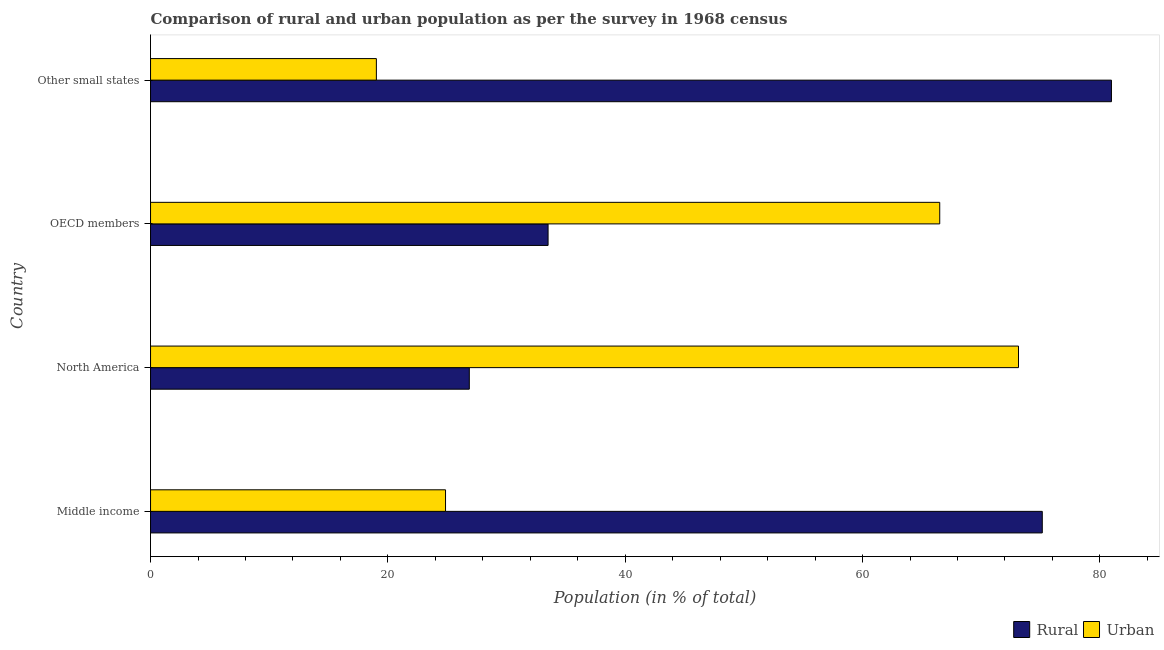How many different coloured bars are there?
Your response must be concise. 2. How many groups of bars are there?
Ensure brevity in your answer.  4. Are the number of bars per tick equal to the number of legend labels?
Provide a short and direct response. Yes. What is the label of the 4th group of bars from the top?
Give a very brief answer. Middle income. What is the urban population in Other small states?
Provide a short and direct response. 19.03. Across all countries, what is the maximum urban population?
Provide a short and direct response. 73.14. Across all countries, what is the minimum rural population?
Give a very brief answer. 26.86. In which country was the rural population maximum?
Make the answer very short. Other small states. In which country was the rural population minimum?
Offer a terse response. North America. What is the total urban population in the graph?
Your answer should be compact. 183.53. What is the difference between the rural population in OECD members and that in Other small states?
Ensure brevity in your answer.  -47.47. What is the difference between the rural population in OECD members and the urban population in Other small states?
Your response must be concise. 14.47. What is the average urban population per country?
Provide a succinct answer. 45.88. What is the difference between the rural population and urban population in OECD members?
Offer a terse response. -33. What is the ratio of the rural population in Middle income to that in OECD members?
Give a very brief answer. 2.24. What is the difference between the highest and the second highest rural population?
Make the answer very short. 5.83. What is the difference between the highest and the lowest urban population?
Your response must be concise. 54.11. In how many countries, is the urban population greater than the average urban population taken over all countries?
Your answer should be compact. 2. Is the sum of the rural population in North America and OECD members greater than the maximum urban population across all countries?
Ensure brevity in your answer.  No. What does the 2nd bar from the top in Middle income represents?
Your response must be concise. Rural. What does the 1st bar from the bottom in Other small states represents?
Your answer should be compact. Rural. Are all the bars in the graph horizontal?
Your answer should be compact. Yes. How many countries are there in the graph?
Your answer should be very brief. 4. What is the difference between two consecutive major ticks on the X-axis?
Offer a very short reply. 20. Are the values on the major ticks of X-axis written in scientific E-notation?
Keep it short and to the point. No. Where does the legend appear in the graph?
Your response must be concise. Bottom right. How many legend labels are there?
Give a very brief answer. 2. What is the title of the graph?
Your response must be concise. Comparison of rural and urban population as per the survey in 1968 census. Does "Arms imports" appear as one of the legend labels in the graph?
Offer a very short reply. No. What is the label or title of the X-axis?
Offer a very short reply. Population (in % of total). What is the label or title of the Y-axis?
Your answer should be compact. Country. What is the Population (in % of total) in Rural in Middle income?
Your answer should be very brief. 75.14. What is the Population (in % of total) in Urban in Middle income?
Keep it short and to the point. 24.86. What is the Population (in % of total) of Rural in North America?
Give a very brief answer. 26.86. What is the Population (in % of total) in Urban in North America?
Provide a short and direct response. 73.14. What is the Population (in % of total) in Rural in OECD members?
Offer a terse response. 33.5. What is the Population (in % of total) in Urban in OECD members?
Provide a short and direct response. 66.5. What is the Population (in % of total) of Rural in Other small states?
Offer a very short reply. 80.97. What is the Population (in % of total) of Urban in Other small states?
Offer a very short reply. 19.03. Across all countries, what is the maximum Population (in % of total) in Rural?
Keep it short and to the point. 80.97. Across all countries, what is the maximum Population (in % of total) of Urban?
Provide a short and direct response. 73.14. Across all countries, what is the minimum Population (in % of total) of Rural?
Offer a very short reply. 26.86. Across all countries, what is the minimum Population (in % of total) in Urban?
Provide a succinct answer. 19.03. What is the total Population (in % of total) of Rural in the graph?
Provide a short and direct response. 216.47. What is the total Population (in % of total) of Urban in the graph?
Give a very brief answer. 183.53. What is the difference between the Population (in % of total) of Rural in Middle income and that in North America?
Provide a succinct answer. 48.28. What is the difference between the Population (in % of total) of Urban in Middle income and that in North America?
Offer a terse response. -48.28. What is the difference between the Population (in % of total) in Rural in Middle income and that in OECD members?
Make the answer very short. 41.64. What is the difference between the Population (in % of total) in Urban in Middle income and that in OECD members?
Your answer should be compact. -41.64. What is the difference between the Population (in % of total) of Rural in Middle income and that in Other small states?
Provide a short and direct response. -5.83. What is the difference between the Population (in % of total) in Urban in Middle income and that in Other small states?
Ensure brevity in your answer.  5.83. What is the difference between the Population (in % of total) of Rural in North America and that in OECD members?
Keep it short and to the point. -6.64. What is the difference between the Population (in % of total) of Urban in North America and that in OECD members?
Keep it short and to the point. 6.64. What is the difference between the Population (in % of total) of Rural in North America and that in Other small states?
Give a very brief answer. -54.11. What is the difference between the Population (in % of total) of Urban in North America and that in Other small states?
Keep it short and to the point. 54.11. What is the difference between the Population (in % of total) of Rural in OECD members and that in Other small states?
Offer a very short reply. -47.47. What is the difference between the Population (in % of total) in Urban in OECD members and that in Other small states?
Keep it short and to the point. 47.47. What is the difference between the Population (in % of total) of Rural in Middle income and the Population (in % of total) of Urban in North America?
Keep it short and to the point. 2. What is the difference between the Population (in % of total) in Rural in Middle income and the Population (in % of total) in Urban in OECD members?
Provide a short and direct response. 8.64. What is the difference between the Population (in % of total) in Rural in Middle income and the Population (in % of total) in Urban in Other small states?
Your answer should be very brief. 56.11. What is the difference between the Population (in % of total) in Rural in North America and the Population (in % of total) in Urban in OECD members?
Your response must be concise. -39.64. What is the difference between the Population (in % of total) in Rural in North America and the Population (in % of total) in Urban in Other small states?
Your response must be concise. 7.83. What is the difference between the Population (in % of total) of Rural in OECD members and the Population (in % of total) of Urban in Other small states?
Make the answer very short. 14.47. What is the average Population (in % of total) in Rural per country?
Your answer should be compact. 54.12. What is the average Population (in % of total) in Urban per country?
Your answer should be very brief. 45.88. What is the difference between the Population (in % of total) in Rural and Population (in % of total) in Urban in Middle income?
Your answer should be very brief. 50.29. What is the difference between the Population (in % of total) of Rural and Population (in % of total) of Urban in North America?
Give a very brief answer. -46.28. What is the difference between the Population (in % of total) of Rural and Population (in % of total) of Urban in OECD members?
Keep it short and to the point. -33. What is the difference between the Population (in % of total) in Rural and Population (in % of total) in Urban in Other small states?
Ensure brevity in your answer.  61.94. What is the ratio of the Population (in % of total) of Rural in Middle income to that in North America?
Your response must be concise. 2.8. What is the ratio of the Population (in % of total) of Urban in Middle income to that in North America?
Make the answer very short. 0.34. What is the ratio of the Population (in % of total) of Rural in Middle income to that in OECD members?
Give a very brief answer. 2.24. What is the ratio of the Population (in % of total) of Urban in Middle income to that in OECD members?
Your response must be concise. 0.37. What is the ratio of the Population (in % of total) of Rural in Middle income to that in Other small states?
Offer a terse response. 0.93. What is the ratio of the Population (in % of total) of Urban in Middle income to that in Other small states?
Provide a short and direct response. 1.31. What is the ratio of the Population (in % of total) in Rural in North America to that in OECD members?
Your response must be concise. 0.8. What is the ratio of the Population (in % of total) of Urban in North America to that in OECD members?
Give a very brief answer. 1.1. What is the ratio of the Population (in % of total) in Rural in North America to that in Other small states?
Offer a very short reply. 0.33. What is the ratio of the Population (in % of total) in Urban in North America to that in Other small states?
Your response must be concise. 3.84. What is the ratio of the Population (in % of total) in Rural in OECD members to that in Other small states?
Make the answer very short. 0.41. What is the ratio of the Population (in % of total) in Urban in OECD members to that in Other small states?
Keep it short and to the point. 3.49. What is the difference between the highest and the second highest Population (in % of total) in Rural?
Your response must be concise. 5.83. What is the difference between the highest and the second highest Population (in % of total) of Urban?
Provide a short and direct response. 6.64. What is the difference between the highest and the lowest Population (in % of total) of Rural?
Offer a very short reply. 54.11. What is the difference between the highest and the lowest Population (in % of total) of Urban?
Your answer should be very brief. 54.11. 